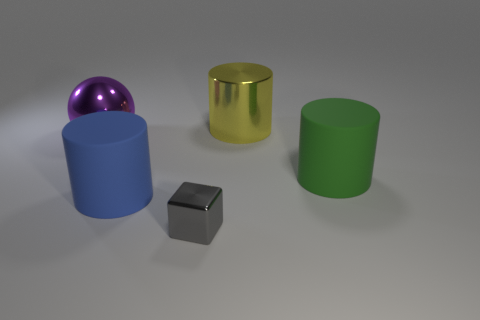How many things are the same color as the shiny ball?
Your answer should be compact. 0. What size is the shiny thing on the right side of the tiny cube?
Provide a short and direct response. Large. There is a thing to the left of the big cylinder in front of the large matte object that is behind the large blue thing; what is its shape?
Your answer should be very brief. Sphere. What is the shape of the thing that is both on the right side of the blue rubber object and in front of the big green thing?
Your answer should be compact. Cube. Is there a green metal ball that has the same size as the purple metallic ball?
Offer a terse response. No. Does the matte object right of the yellow metal object have the same shape as the large purple shiny object?
Your response must be concise. No. Do the big green rubber object and the gray metal thing have the same shape?
Ensure brevity in your answer.  No. Are there any blue rubber objects of the same shape as the big green matte thing?
Your response must be concise. Yes. What shape is the shiny object that is behind the big purple sphere that is to the left of the metal cylinder?
Provide a succinct answer. Cylinder. There is a metal thing left of the big blue object; what color is it?
Ensure brevity in your answer.  Purple. 